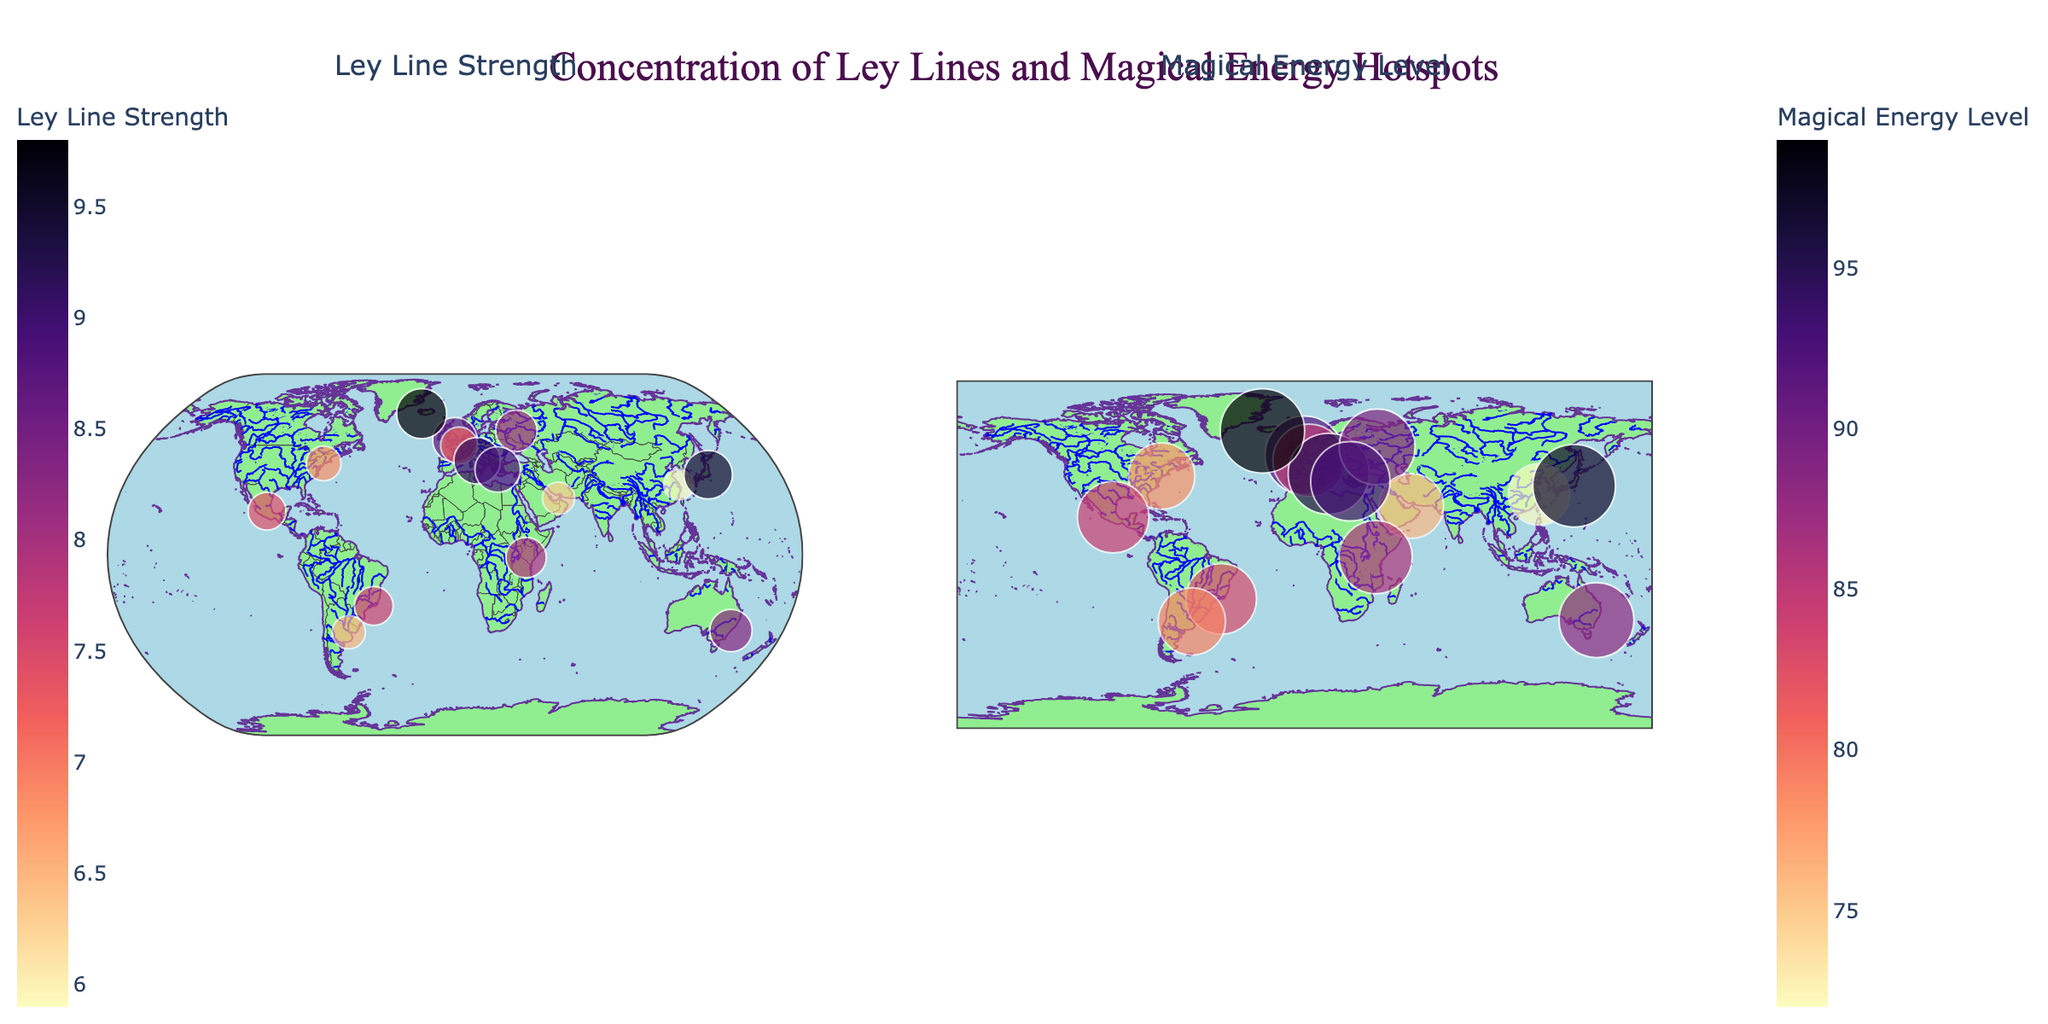What is the title of the figure? The title of the figure is located at the top of the image. It usually serves as a quick summary of what the plot represents. By inspecting the plot, you can read the title directly.
Answer: Concentration of Ley Lines and Magical Energy Hotspots How many data points are shown on the map for the Ley Line Strength? By counting the number of markers (dots) on the first subplot for Ley Line Strength, we can determine the number of data points.
Answer: 14 Which location has the highest Ley Line Strength? The color intensity and size of the markers in the Ley Line Strength subplot indicate the strength. By finding the largest and most intense marker, you can identify this location.
Answer: Reykjavik What is the general color scheme used for the markers? The colors of the markers can be identified by observing the color scale provided in the color bar on the side of the plots. A commonly used color scheme in such plots is often named in the plot metadata.
Answer: Magma Which locations have both high Ley Line Strength and high Magical Energy Level? Look for markers in both subplots that are large and intense in color. By cross-referencing these markers, you can identify the overlapping locations with high values in both metrics.
Answer: Reykjavik, Tokyo, Rome, Athens What is the average Ley Line Strength across all locations? Add up all the Ley Line Strength values and divide by the number of locations. (8.7 + 7.2 + 9.1 + 6.8 + 5.9 + 8.3 + 7.6 + 9.5 + 8.1 + 6.3 + 7.9 + 6.5 + 8.9 + 7.4 + 9.8) / 15.
Answer: 8.3 Which city has the lowest Magical Energy Level, and what is its value? By finding the smallest marker size and least intense color in the Magical Energy Level subplot, you can identify this city and its corresponding value.
Answer: Shanghai, 72 What is the difference in Ley Line Strength between Tokyo and New York City? Ley Line Strength for Tokyo is 9.5, and for New York City, it is 6.8. Subtract the smaller value from the larger one to find the difference.
Answer: 2.7 Describe the geographical trend of high Ley Line Strength locations. High Ley Line Strength is depicted with larger markers. By observing the geographical distribution of large markers, you can discern a pattern. These locations seem to have a certain spread or commonality.
Answer: They are major global cities, often the capitals or key cultural centers What is the sum of the Magical Energy Levels for London, Paris, and Rome? Add Magical Energy Levels for these three cities. 92 (London) + 85 (Paris) + 95 (Rome).
Answer: 272 